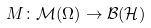<formula> <loc_0><loc_0><loc_500><loc_500>M \colon \mathcal { M } ( \Omega ) \rightarrow \mathcal { B } ( \mathcal { H } )</formula> 